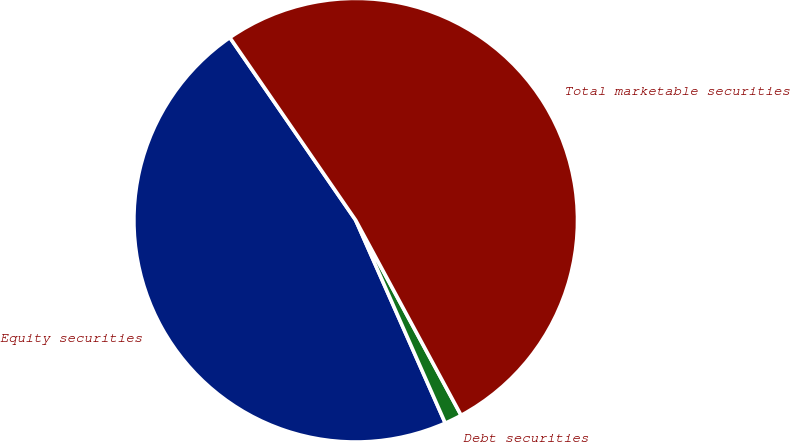Convert chart to OTSL. <chart><loc_0><loc_0><loc_500><loc_500><pie_chart><fcel>Equity securities<fcel>Debt securities<fcel>Total marketable securities<nl><fcel>47.01%<fcel>1.27%<fcel>51.71%<nl></chart> 